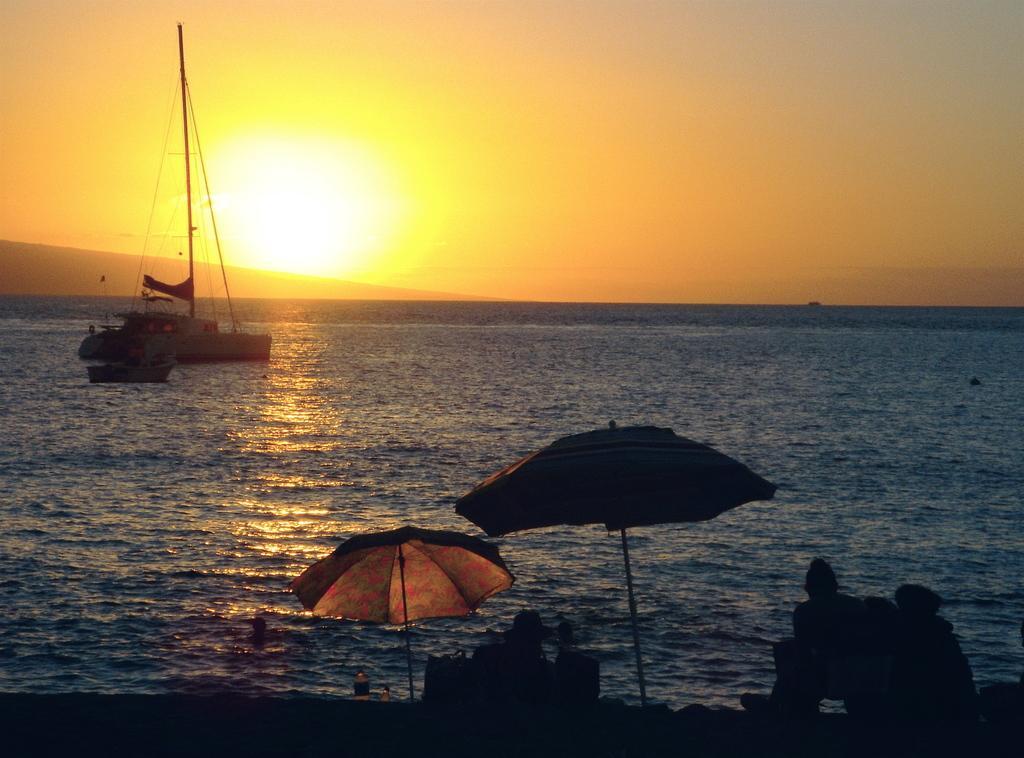How would you summarize this image in a sentence or two? In this image there is a ship and a boat on the river, in the foreground of the image there are two umbrellas and a few people are sitting, there are a few objects. In the background there is the sky. 